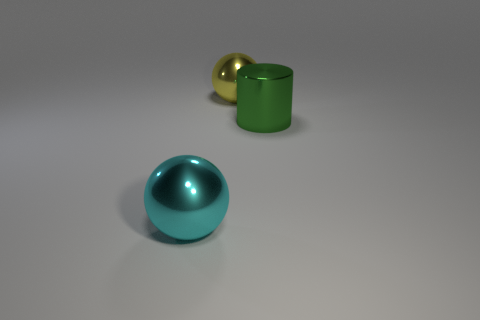Add 2 small yellow rubber blocks. How many objects exist? 5 Subtract all cylinders. How many objects are left? 2 Subtract 0 green cubes. How many objects are left? 3 Subtract all big yellow metal things. Subtract all large green cylinders. How many objects are left? 1 Add 2 large green objects. How many large green objects are left? 3 Add 3 big purple metal things. How many big purple metal things exist? 3 